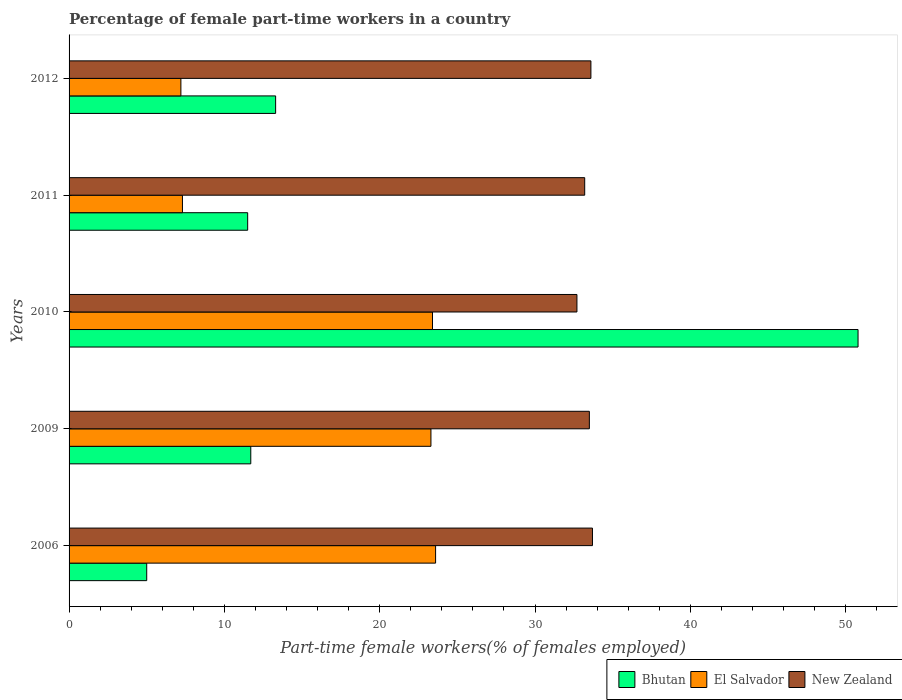How many different coloured bars are there?
Your answer should be compact. 3. How many groups of bars are there?
Your answer should be very brief. 5. Are the number of bars per tick equal to the number of legend labels?
Make the answer very short. Yes. In how many cases, is the number of bars for a given year not equal to the number of legend labels?
Offer a very short reply. 0. What is the percentage of female part-time workers in El Salvador in 2006?
Give a very brief answer. 23.6. Across all years, what is the maximum percentage of female part-time workers in Bhutan?
Your response must be concise. 50.8. Across all years, what is the minimum percentage of female part-time workers in El Salvador?
Ensure brevity in your answer.  7.2. In which year was the percentage of female part-time workers in Bhutan maximum?
Ensure brevity in your answer.  2010. In which year was the percentage of female part-time workers in Bhutan minimum?
Ensure brevity in your answer.  2006. What is the total percentage of female part-time workers in Bhutan in the graph?
Give a very brief answer. 92.3. What is the difference between the percentage of female part-time workers in El Salvador in 2010 and that in 2012?
Keep it short and to the point. 16.2. What is the difference between the percentage of female part-time workers in Bhutan in 2010 and the percentage of female part-time workers in El Salvador in 2009?
Your answer should be compact. 27.5. What is the average percentage of female part-time workers in Bhutan per year?
Your answer should be very brief. 18.46. In the year 2009, what is the difference between the percentage of female part-time workers in Bhutan and percentage of female part-time workers in New Zealand?
Make the answer very short. -21.8. What is the ratio of the percentage of female part-time workers in New Zealand in 2006 to that in 2009?
Provide a succinct answer. 1.01. Is the difference between the percentage of female part-time workers in Bhutan in 2011 and 2012 greater than the difference between the percentage of female part-time workers in New Zealand in 2011 and 2012?
Ensure brevity in your answer.  No. What is the difference between the highest and the second highest percentage of female part-time workers in Bhutan?
Ensure brevity in your answer.  37.5. What is the difference between the highest and the lowest percentage of female part-time workers in Bhutan?
Provide a succinct answer. 45.8. In how many years, is the percentage of female part-time workers in New Zealand greater than the average percentage of female part-time workers in New Zealand taken over all years?
Offer a very short reply. 3. What does the 1st bar from the top in 2011 represents?
Provide a short and direct response. New Zealand. What does the 1st bar from the bottom in 2009 represents?
Keep it short and to the point. Bhutan. Is it the case that in every year, the sum of the percentage of female part-time workers in Bhutan and percentage of female part-time workers in El Salvador is greater than the percentage of female part-time workers in New Zealand?
Offer a terse response. No. How many bars are there?
Give a very brief answer. 15. How many years are there in the graph?
Your answer should be very brief. 5. What is the difference between two consecutive major ticks on the X-axis?
Offer a terse response. 10. Does the graph contain grids?
Offer a very short reply. No. Where does the legend appear in the graph?
Offer a terse response. Bottom right. How many legend labels are there?
Your answer should be very brief. 3. How are the legend labels stacked?
Offer a very short reply. Horizontal. What is the title of the graph?
Provide a short and direct response. Percentage of female part-time workers in a country. What is the label or title of the X-axis?
Your answer should be very brief. Part-time female workers(% of females employed). What is the label or title of the Y-axis?
Your answer should be compact. Years. What is the Part-time female workers(% of females employed) in Bhutan in 2006?
Provide a short and direct response. 5. What is the Part-time female workers(% of females employed) of El Salvador in 2006?
Offer a very short reply. 23.6. What is the Part-time female workers(% of females employed) of New Zealand in 2006?
Offer a very short reply. 33.7. What is the Part-time female workers(% of females employed) in Bhutan in 2009?
Provide a succinct answer. 11.7. What is the Part-time female workers(% of females employed) of El Salvador in 2009?
Keep it short and to the point. 23.3. What is the Part-time female workers(% of females employed) of New Zealand in 2009?
Ensure brevity in your answer.  33.5. What is the Part-time female workers(% of females employed) of Bhutan in 2010?
Keep it short and to the point. 50.8. What is the Part-time female workers(% of females employed) of El Salvador in 2010?
Give a very brief answer. 23.4. What is the Part-time female workers(% of females employed) of New Zealand in 2010?
Provide a short and direct response. 32.7. What is the Part-time female workers(% of females employed) of Bhutan in 2011?
Offer a terse response. 11.5. What is the Part-time female workers(% of females employed) in El Salvador in 2011?
Your response must be concise. 7.3. What is the Part-time female workers(% of females employed) in New Zealand in 2011?
Ensure brevity in your answer.  33.2. What is the Part-time female workers(% of females employed) of Bhutan in 2012?
Offer a terse response. 13.3. What is the Part-time female workers(% of females employed) in El Salvador in 2012?
Give a very brief answer. 7.2. What is the Part-time female workers(% of females employed) in New Zealand in 2012?
Provide a succinct answer. 33.6. Across all years, what is the maximum Part-time female workers(% of females employed) of Bhutan?
Your response must be concise. 50.8. Across all years, what is the maximum Part-time female workers(% of females employed) of El Salvador?
Keep it short and to the point. 23.6. Across all years, what is the maximum Part-time female workers(% of females employed) in New Zealand?
Keep it short and to the point. 33.7. Across all years, what is the minimum Part-time female workers(% of females employed) in El Salvador?
Your answer should be compact. 7.2. Across all years, what is the minimum Part-time female workers(% of females employed) in New Zealand?
Provide a succinct answer. 32.7. What is the total Part-time female workers(% of females employed) of Bhutan in the graph?
Offer a terse response. 92.3. What is the total Part-time female workers(% of females employed) of El Salvador in the graph?
Offer a very short reply. 84.8. What is the total Part-time female workers(% of females employed) in New Zealand in the graph?
Give a very brief answer. 166.7. What is the difference between the Part-time female workers(% of females employed) of Bhutan in 2006 and that in 2010?
Offer a terse response. -45.8. What is the difference between the Part-time female workers(% of females employed) in El Salvador in 2006 and that in 2010?
Provide a succinct answer. 0.2. What is the difference between the Part-time female workers(% of females employed) in New Zealand in 2006 and that in 2011?
Provide a succinct answer. 0.5. What is the difference between the Part-time female workers(% of females employed) of Bhutan in 2006 and that in 2012?
Your response must be concise. -8.3. What is the difference between the Part-time female workers(% of females employed) of El Salvador in 2006 and that in 2012?
Your response must be concise. 16.4. What is the difference between the Part-time female workers(% of females employed) of Bhutan in 2009 and that in 2010?
Your response must be concise. -39.1. What is the difference between the Part-time female workers(% of females employed) in El Salvador in 2009 and that in 2010?
Your response must be concise. -0.1. What is the difference between the Part-time female workers(% of females employed) in New Zealand in 2009 and that in 2010?
Keep it short and to the point. 0.8. What is the difference between the Part-time female workers(% of females employed) in Bhutan in 2009 and that in 2011?
Your response must be concise. 0.2. What is the difference between the Part-time female workers(% of females employed) of Bhutan in 2009 and that in 2012?
Ensure brevity in your answer.  -1.6. What is the difference between the Part-time female workers(% of females employed) in New Zealand in 2009 and that in 2012?
Keep it short and to the point. -0.1. What is the difference between the Part-time female workers(% of females employed) of Bhutan in 2010 and that in 2011?
Offer a very short reply. 39.3. What is the difference between the Part-time female workers(% of females employed) in El Salvador in 2010 and that in 2011?
Keep it short and to the point. 16.1. What is the difference between the Part-time female workers(% of females employed) of Bhutan in 2010 and that in 2012?
Your response must be concise. 37.5. What is the difference between the Part-time female workers(% of females employed) of El Salvador in 2010 and that in 2012?
Offer a terse response. 16.2. What is the difference between the Part-time female workers(% of females employed) of New Zealand in 2011 and that in 2012?
Your answer should be very brief. -0.4. What is the difference between the Part-time female workers(% of females employed) in Bhutan in 2006 and the Part-time female workers(% of females employed) in El Salvador in 2009?
Keep it short and to the point. -18.3. What is the difference between the Part-time female workers(% of females employed) of Bhutan in 2006 and the Part-time female workers(% of females employed) of New Zealand in 2009?
Your answer should be very brief. -28.5. What is the difference between the Part-time female workers(% of females employed) in El Salvador in 2006 and the Part-time female workers(% of females employed) in New Zealand in 2009?
Keep it short and to the point. -9.9. What is the difference between the Part-time female workers(% of females employed) of Bhutan in 2006 and the Part-time female workers(% of females employed) of El Salvador in 2010?
Offer a very short reply. -18.4. What is the difference between the Part-time female workers(% of females employed) of Bhutan in 2006 and the Part-time female workers(% of females employed) of New Zealand in 2010?
Provide a succinct answer. -27.7. What is the difference between the Part-time female workers(% of females employed) in Bhutan in 2006 and the Part-time female workers(% of females employed) in El Salvador in 2011?
Your response must be concise. -2.3. What is the difference between the Part-time female workers(% of females employed) in Bhutan in 2006 and the Part-time female workers(% of females employed) in New Zealand in 2011?
Provide a short and direct response. -28.2. What is the difference between the Part-time female workers(% of females employed) in El Salvador in 2006 and the Part-time female workers(% of females employed) in New Zealand in 2011?
Make the answer very short. -9.6. What is the difference between the Part-time female workers(% of females employed) in Bhutan in 2006 and the Part-time female workers(% of females employed) in New Zealand in 2012?
Give a very brief answer. -28.6. What is the difference between the Part-time female workers(% of females employed) of El Salvador in 2009 and the Part-time female workers(% of females employed) of New Zealand in 2010?
Offer a terse response. -9.4. What is the difference between the Part-time female workers(% of females employed) in Bhutan in 2009 and the Part-time female workers(% of females employed) in New Zealand in 2011?
Keep it short and to the point. -21.5. What is the difference between the Part-time female workers(% of females employed) of Bhutan in 2009 and the Part-time female workers(% of females employed) of New Zealand in 2012?
Your answer should be compact. -21.9. What is the difference between the Part-time female workers(% of females employed) in Bhutan in 2010 and the Part-time female workers(% of females employed) in El Salvador in 2011?
Your answer should be very brief. 43.5. What is the difference between the Part-time female workers(% of females employed) in Bhutan in 2010 and the Part-time female workers(% of females employed) in El Salvador in 2012?
Keep it short and to the point. 43.6. What is the difference between the Part-time female workers(% of females employed) of Bhutan in 2010 and the Part-time female workers(% of females employed) of New Zealand in 2012?
Offer a terse response. 17.2. What is the difference between the Part-time female workers(% of females employed) of El Salvador in 2010 and the Part-time female workers(% of females employed) of New Zealand in 2012?
Your answer should be compact. -10.2. What is the difference between the Part-time female workers(% of females employed) of Bhutan in 2011 and the Part-time female workers(% of females employed) of El Salvador in 2012?
Offer a very short reply. 4.3. What is the difference between the Part-time female workers(% of females employed) of Bhutan in 2011 and the Part-time female workers(% of females employed) of New Zealand in 2012?
Offer a terse response. -22.1. What is the difference between the Part-time female workers(% of females employed) of El Salvador in 2011 and the Part-time female workers(% of females employed) of New Zealand in 2012?
Make the answer very short. -26.3. What is the average Part-time female workers(% of females employed) of Bhutan per year?
Provide a succinct answer. 18.46. What is the average Part-time female workers(% of females employed) of El Salvador per year?
Keep it short and to the point. 16.96. What is the average Part-time female workers(% of females employed) in New Zealand per year?
Offer a very short reply. 33.34. In the year 2006, what is the difference between the Part-time female workers(% of females employed) of Bhutan and Part-time female workers(% of females employed) of El Salvador?
Ensure brevity in your answer.  -18.6. In the year 2006, what is the difference between the Part-time female workers(% of females employed) in Bhutan and Part-time female workers(% of females employed) in New Zealand?
Your answer should be very brief. -28.7. In the year 2006, what is the difference between the Part-time female workers(% of females employed) in El Salvador and Part-time female workers(% of females employed) in New Zealand?
Give a very brief answer. -10.1. In the year 2009, what is the difference between the Part-time female workers(% of females employed) in Bhutan and Part-time female workers(% of females employed) in El Salvador?
Make the answer very short. -11.6. In the year 2009, what is the difference between the Part-time female workers(% of females employed) in Bhutan and Part-time female workers(% of females employed) in New Zealand?
Keep it short and to the point. -21.8. In the year 2010, what is the difference between the Part-time female workers(% of females employed) of Bhutan and Part-time female workers(% of females employed) of El Salvador?
Provide a short and direct response. 27.4. In the year 2011, what is the difference between the Part-time female workers(% of females employed) in Bhutan and Part-time female workers(% of females employed) in New Zealand?
Offer a very short reply. -21.7. In the year 2011, what is the difference between the Part-time female workers(% of females employed) of El Salvador and Part-time female workers(% of females employed) of New Zealand?
Your answer should be compact. -25.9. In the year 2012, what is the difference between the Part-time female workers(% of females employed) of Bhutan and Part-time female workers(% of females employed) of El Salvador?
Your answer should be compact. 6.1. In the year 2012, what is the difference between the Part-time female workers(% of females employed) of Bhutan and Part-time female workers(% of females employed) of New Zealand?
Provide a short and direct response. -20.3. In the year 2012, what is the difference between the Part-time female workers(% of females employed) in El Salvador and Part-time female workers(% of females employed) in New Zealand?
Offer a terse response. -26.4. What is the ratio of the Part-time female workers(% of females employed) of Bhutan in 2006 to that in 2009?
Provide a short and direct response. 0.43. What is the ratio of the Part-time female workers(% of females employed) of El Salvador in 2006 to that in 2009?
Make the answer very short. 1.01. What is the ratio of the Part-time female workers(% of females employed) of New Zealand in 2006 to that in 2009?
Provide a short and direct response. 1.01. What is the ratio of the Part-time female workers(% of females employed) of Bhutan in 2006 to that in 2010?
Ensure brevity in your answer.  0.1. What is the ratio of the Part-time female workers(% of females employed) of El Salvador in 2006 to that in 2010?
Ensure brevity in your answer.  1.01. What is the ratio of the Part-time female workers(% of females employed) in New Zealand in 2006 to that in 2010?
Provide a short and direct response. 1.03. What is the ratio of the Part-time female workers(% of females employed) of Bhutan in 2006 to that in 2011?
Your answer should be compact. 0.43. What is the ratio of the Part-time female workers(% of females employed) in El Salvador in 2006 to that in 2011?
Provide a succinct answer. 3.23. What is the ratio of the Part-time female workers(% of females employed) in New Zealand in 2006 to that in 2011?
Provide a succinct answer. 1.02. What is the ratio of the Part-time female workers(% of females employed) of Bhutan in 2006 to that in 2012?
Your response must be concise. 0.38. What is the ratio of the Part-time female workers(% of females employed) in El Salvador in 2006 to that in 2012?
Ensure brevity in your answer.  3.28. What is the ratio of the Part-time female workers(% of females employed) of Bhutan in 2009 to that in 2010?
Offer a terse response. 0.23. What is the ratio of the Part-time female workers(% of females employed) in New Zealand in 2009 to that in 2010?
Ensure brevity in your answer.  1.02. What is the ratio of the Part-time female workers(% of females employed) in Bhutan in 2009 to that in 2011?
Your answer should be very brief. 1.02. What is the ratio of the Part-time female workers(% of females employed) of El Salvador in 2009 to that in 2011?
Give a very brief answer. 3.19. What is the ratio of the Part-time female workers(% of females employed) in Bhutan in 2009 to that in 2012?
Your answer should be compact. 0.88. What is the ratio of the Part-time female workers(% of females employed) of El Salvador in 2009 to that in 2012?
Provide a short and direct response. 3.24. What is the ratio of the Part-time female workers(% of females employed) of New Zealand in 2009 to that in 2012?
Your response must be concise. 1. What is the ratio of the Part-time female workers(% of females employed) in Bhutan in 2010 to that in 2011?
Keep it short and to the point. 4.42. What is the ratio of the Part-time female workers(% of females employed) in El Salvador in 2010 to that in 2011?
Make the answer very short. 3.21. What is the ratio of the Part-time female workers(% of females employed) of New Zealand in 2010 to that in 2011?
Keep it short and to the point. 0.98. What is the ratio of the Part-time female workers(% of females employed) in Bhutan in 2010 to that in 2012?
Give a very brief answer. 3.82. What is the ratio of the Part-time female workers(% of females employed) in New Zealand in 2010 to that in 2012?
Offer a terse response. 0.97. What is the ratio of the Part-time female workers(% of females employed) in Bhutan in 2011 to that in 2012?
Provide a succinct answer. 0.86. What is the ratio of the Part-time female workers(% of females employed) of El Salvador in 2011 to that in 2012?
Provide a short and direct response. 1.01. What is the difference between the highest and the second highest Part-time female workers(% of females employed) of Bhutan?
Your answer should be very brief. 37.5. What is the difference between the highest and the lowest Part-time female workers(% of females employed) in Bhutan?
Keep it short and to the point. 45.8. What is the difference between the highest and the lowest Part-time female workers(% of females employed) of El Salvador?
Your response must be concise. 16.4. 